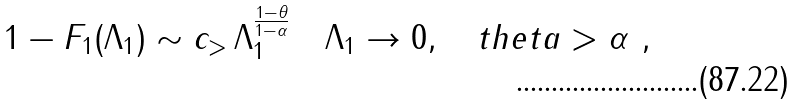<formula> <loc_0><loc_0><loc_500><loc_500>1 - F _ { 1 } ( \Lambda _ { 1 } ) \sim c _ { > } \, \Lambda _ { 1 } ^ { \frac { 1 - \theta } { 1 - \alpha } } \quad \Lambda _ { 1 } \to 0 , \quad t h e t a > \alpha \ ,</formula> 